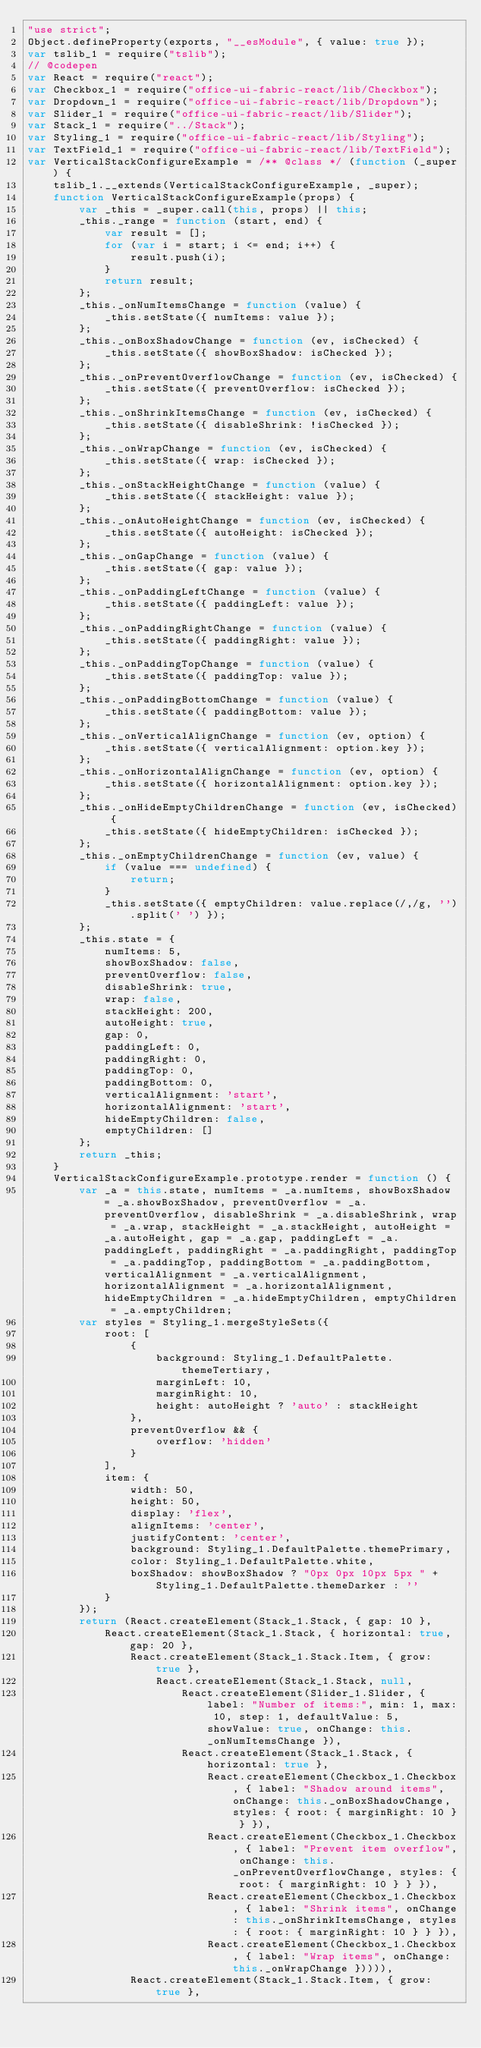<code> <loc_0><loc_0><loc_500><loc_500><_JavaScript_>"use strict";
Object.defineProperty(exports, "__esModule", { value: true });
var tslib_1 = require("tslib");
// @codepen
var React = require("react");
var Checkbox_1 = require("office-ui-fabric-react/lib/Checkbox");
var Dropdown_1 = require("office-ui-fabric-react/lib/Dropdown");
var Slider_1 = require("office-ui-fabric-react/lib/Slider");
var Stack_1 = require("../Stack");
var Styling_1 = require("office-ui-fabric-react/lib/Styling");
var TextField_1 = require("office-ui-fabric-react/lib/TextField");
var VerticalStackConfigureExample = /** @class */ (function (_super) {
    tslib_1.__extends(VerticalStackConfigureExample, _super);
    function VerticalStackConfigureExample(props) {
        var _this = _super.call(this, props) || this;
        _this._range = function (start, end) {
            var result = [];
            for (var i = start; i <= end; i++) {
                result.push(i);
            }
            return result;
        };
        _this._onNumItemsChange = function (value) {
            _this.setState({ numItems: value });
        };
        _this._onBoxShadowChange = function (ev, isChecked) {
            _this.setState({ showBoxShadow: isChecked });
        };
        _this._onPreventOverflowChange = function (ev, isChecked) {
            _this.setState({ preventOverflow: isChecked });
        };
        _this._onShrinkItemsChange = function (ev, isChecked) {
            _this.setState({ disableShrink: !isChecked });
        };
        _this._onWrapChange = function (ev, isChecked) {
            _this.setState({ wrap: isChecked });
        };
        _this._onStackHeightChange = function (value) {
            _this.setState({ stackHeight: value });
        };
        _this._onAutoHeightChange = function (ev, isChecked) {
            _this.setState({ autoHeight: isChecked });
        };
        _this._onGapChange = function (value) {
            _this.setState({ gap: value });
        };
        _this._onPaddingLeftChange = function (value) {
            _this.setState({ paddingLeft: value });
        };
        _this._onPaddingRightChange = function (value) {
            _this.setState({ paddingRight: value });
        };
        _this._onPaddingTopChange = function (value) {
            _this.setState({ paddingTop: value });
        };
        _this._onPaddingBottomChange = function (value) {
            _this.setState({ paddingBottom: value });
        };
        _this._onVerticalAlignChange = function (ev, option) {
            _this.setState({ verticalAlignment: option.key });
        };
        _this._onHorizontalAlignChange = function (ev, option) {
            _this.setState({ horizontalAlignment: option.key });
        };
        _this._onHideEmptyChildrenChange = function (ev, isChecked) {
            _this.setState({ hideEmptyChildren: isChecked });
        };
        _this._onEmptyChildrenChange = function (ev, value) {
            if (value === undefined) {
                return;
            }
            _this.setState({ emptyChildren: value.replace(/,/g, '').split(' ') });
        };
        _this.state = {
            numItems: 5,
            showBoxShadow: false,
            preventOverflow: false,
            disableShrink: true,
            wrap: false,
            stackHeight: 200,
            autoHeight: true,
            gap: 0,
            paddingLeft: 0,
            paddingRight: 0,
            paddingTop: 0,
            paddingBottom: 0,
            verticalAlignment: 'start',
            horizontalAlignment: 'start',
            hideEmptyChildren: false,
            emptyChildren: []
        };
        return _this;
    }
    VerticalStackConfigureExample.prototype.render = function () {
        var _a = this.state, numItems = _a.numItems, showBoxShadow = _a.showBoxShadow, preventOverflow = _a.preventOverflow, disableShrink = _a.disableShrink, wrap = _a.wrap, stackHeight = _a.stackHeight, autoHeight = _a.autoHeight, gap = _a.gap, paddingLeft = _a.paddingLeft, paddingRight = _a.paddingRight, paddingTop = _a.paddingTop, paddingBottom = _a.paddingBottom, verticalAlignment = _a.verticalAlignment, horizontalAlignment = _a.horizontalAlignment, hideEmptyChildren = _a.hideEmptyChildren, emptyChildren = _a.emptyChildren;
        var styles = Styling_1.mergeStyleSets({
            root: [
                {
                    background: Styling_1.DefaultPalette.themeTertiary,
                    marginLeft: 10,
                    marginRight: 10,
                    height: autoHeight ? 'auto' : stackHeight
                },
                preventOverflow && {
                    overflow: 'hidden'
                }
            ],
            item: {
                width: 50,
                height: 50,
                display: 'flex',
                alignItems: 'center',
                justifyContent: 'center',
                background: Styling_1.DefaultPalette.themePrimary,
                color: Styling_1.DefaultPalette.white,
                boxShadow: showBoxShadow ? "0px 0px 10px 5px " + Styling_1.DefaultPalette.themeDarker : ''
            }
        });
        return (React.createElement(Stack_1.Stack, { gap: 10 },
            React.createElement(Stack_1.Stack, { horizontal: true, gap: 20 },
                React.createElement(Stack_1.Stack.Item, { grow: true },
                    React.createElement(Stack_1.Stack, null,
                        React.createElement(Slider_1.Slider, { label: "Number of items:", min: 1, max: 10, step: 1, defaultValue: 5, showValue: true, onChange: this._onNumItemsChange }),
                        React.createElement(Stack_1.Stack, { horizontal: true },
                            React.createElement(Checkbox_1.Checkbox, { label: "Shadow around items", onChange: this._onBoxShadowChange, styles: { root: { marginRight: 10 } } }),
                            React.createElement(Checkbox_1.Checkbox, { label: "Prevent item overflow", onChange: this._onPreventOverflowChange, styles: { root: { marginRight: 10 } } }),
                            React.createElement(Checkbox_1.Checkbox, { label: "Shrink items", onChange: this._onShrinkItemsChange, styles: { root: { marginRight: 10 } } }),
                            React.createElement(Checkbox_1.Checkbox, { label: "Wrap items", onChange: this._onWrapChange })))),
                React.createElement(Stack_1.Stack.Item, { grow: true },</code> 